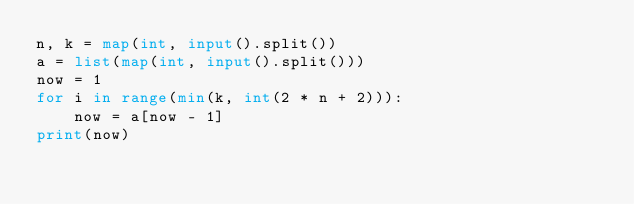<code> <loc_0><loc_0><loc_500><loc_500><_Python_>n, k = map(int, input().split())
a = list(map(int, input().split()))
now = 1
for i in range(min(k, int(2 * n + 2))):
    now = a[now - 1]
print(now)</code> 